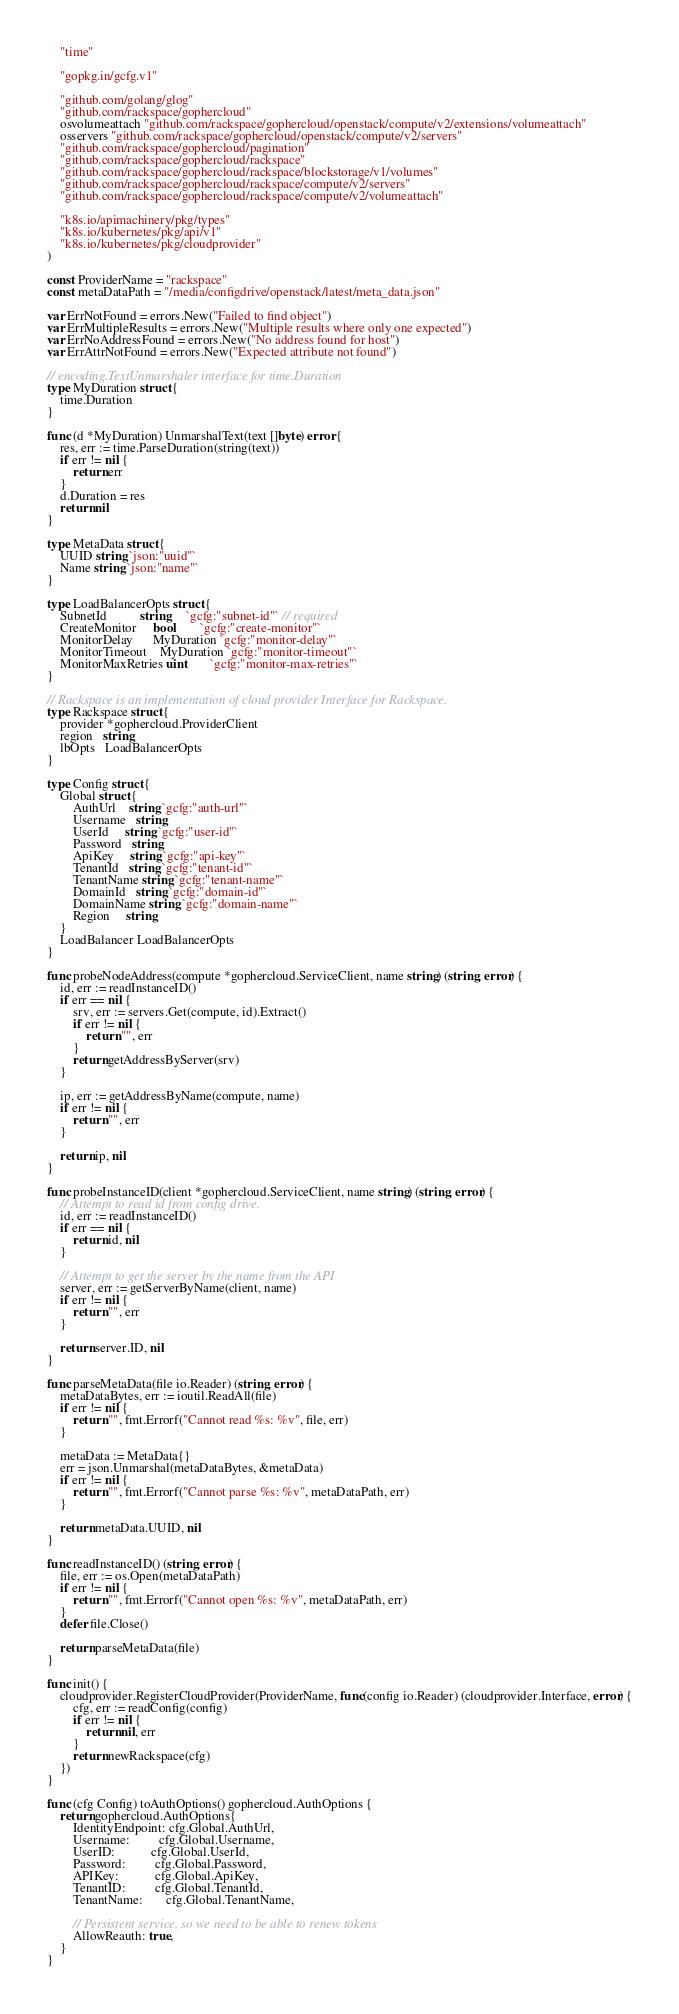Convert code to text. <code><loc_0><loc_0><loc_500><loc_500><_Go_>	"time"

	"gopkg.in/gcfg.v1"

	"github.com/golang/glog"
	"github.com/rackspace/gophercloud"
	osvolumeattach "github.com/rackspace/gophercloud/openstack/compute/v2/extensions/volumeattach"
	osservers "github.com/rackspace/gophercloud/openstack/compute/v2/servers"
	"github.com/rackspace/gophercloud/pagination"
	"github.com/rackspace/gophercloud/rackspace"
	"github.com/rackspace/gophercloud/rackspace/blockstorage/v1/volumes"
	"github.com/rackspace/gophercloud/rackspace/compute/v2/servers"
	"github.com/rackspace/gophercloud/rackspace/compute/v2/volumeattach"

	"k8s.io/apimachinery/pkg/types"
	"k8s.io/kubernetes/pkg/api/v1"
	"k8s.io/kubernetes/pkg/cloudprovider"
)

const ProviderName = "rackspace"
const metaDataPath = "/media/configdrive/openstack/latest/meta_data.json"

var ErrNotFound = errors.New("Failed to find object")
var ErrMultipleResults = errors.New("Multiple results where only one expected")
var ErrNoAddressFound = errors.New("No address found for host")
var ErrAttrNotFound = errors.New("Expected attribute not found")

// encoding.TextUnmarshaler interface for time.Duration
type MyDuration struct {
	time.Duration
}

func (d *MyDuration) UnmarshalText(text []byte) error {
	res, err := time.ParseDuration(string(text))
	if err != nil {
		return err
	}
	d.Duration = res
	return nil
}

type MetaData struct {
	UUID string `json:"uuid"`
	Name string `json:"name"`
}

type LoadBalancerOpts struct {
	SubnetId          string     `gcfg:"subnet-id"` // required
	CreateMonitor     bool       `gcfg:"create-monitor"`
	MonitorDelay      MyDuration `gcfg:"monitor-delay"`
	MonitorTimeout    MyDuration `gcfg:"monitor-timeout"`
	MonitorMaxRetries uint       `gcfg:"monitor-max-retries"`
}

// Rackspace is an implementation of cloud provider Interface for Rackspace.
type Rackspace struct {
	provider *gophercloud.ProviderClient
	region   string
	lbOpts   LoadBalancerOpts
}

type Config struct {
	Global struct {
		AuthUrl    string `gcfg:"auth-url"`
		Username   string
		UserId     string `gcfg:"user-id"`
		Password   string
		ApiKey     string `gcfg:"api-key"`
		TenantId   string `gcfg:"tenant-id"`
		TenantName string `gcfg:"tenant-name"`
		DomainId   string `gcfg:"domain-id"`
		DomainName string `gcfg:"domain-name"`
		Region     string
	}
	LoadBalancer LoadBalancerOpts
}

func probeNodeAddress(compute *gophercloud.ServiceClient, name string) (string, error) {
	id, err := readInstanceID()
	if err == nil {
		srv, err := servers.Get(compute, id).Extract()
		if err != nil {
			return "", err
		}
		return getAddressByServer(srv)
	}

	ip, err := getAddressByName(compute, name)
	if err != nil {
		return "", err
	}

	return ip, nil
}

func probeInstanceID(client *gophercloud.ServiceClient, name string) (string, error) {
	// Attempt to read id from config drive.
	id, err := readInstanceID()
	if err == nil {
		return id, nil
	}

	// Attempt to get the server by the name from the API
	server, err := getServerByName(client, name)
	if err != nil {
		return "", err
	}

	return server.ID, nil
}

func parseMetaData(file io.Reader) (string, error) {
	metaDataBytes, err := ioutil.ReadAll(file)
	if err != nil {
		return "", fmt.Errorf("Cannot read %s: %v", file, err)
	}

	metaData := MetaData{}
	err = json.Unmarshal(metaDataBytes, &metaData)
	if err != nil {
		return "", fmt.Errorf("Cannot parse %s: %v", metaDataPath, err)
	}

	return metaData.UUID, nil
}

func readInstanceID() (string, error) {
	file, err := os.Open(metaDataPath)
	if err != nil {
		return "", fmt.Errorf("Cannot open %s: %v", metaDataPath, err)
	}
	defer file.Close()

	return parseMetaData(file)
}

func init() {
	cloudprovider.RegisterCloudProvider(ProviderName, func(config io.Reader) (cloudprovider.Interface, error) {
		cfg, err := readConfig(config)
		if err != nil {
			return nil, err
		}
		return newRackspace(cfg)
	})
}

func (cfg Config) toAuthOptions() gophercloud.AuthOptions {
	return gophercloud.AuthOptions{
		IdentityEndpoint: cfg.Global.AuthUrl,
		Username:         cfg.Global.Username,
		UserID:           cfg.Global.UserId,
		Password:         cfg.Global.Password,
		APIKey:           cfg.Global.ApiKey,
		TenantID:         cfg.Global.TenantId,
		TenantName:       cfg.Global.TenantName,

		// Persistent service, so we need to be able to renew tokens
		AllowReauth: true,
	}
}
</code> 